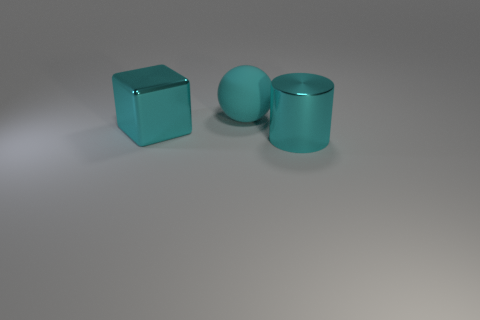Add 2 big green shiny balls. How many objects exist? 5 Subtract all spheres. How many objects are left? 2 Add 2 cylinders. How many cylinders are left? 3 Add 3 matte things. How many matte things exist? 4 Subtract 0 yellow cubes. How many objects are left? 3 Subtract all large cylinders. Subtract all cyan matte things. How many objects are left? 1 